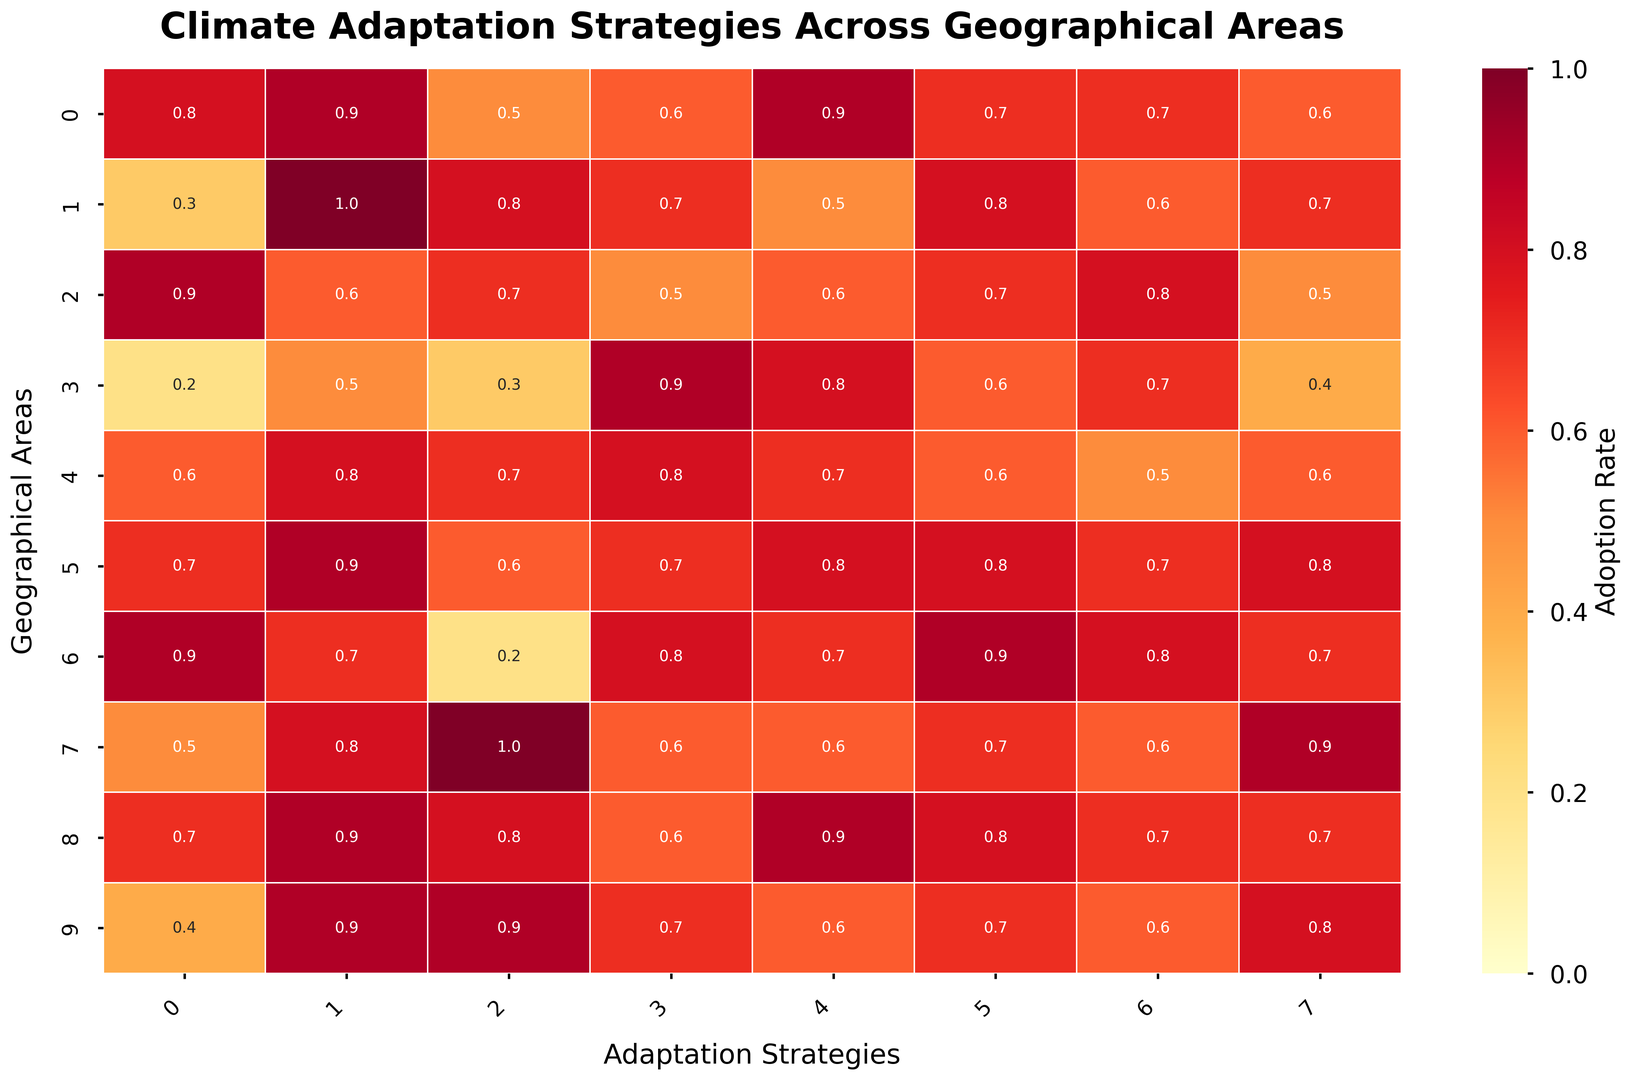What's the most adopted climate adaptation strategy in Coastal Regions? First, identify the row corresponding to Coastal Regions. Then, look across the row to find the highest value. The column with the highest value represents the most adopted strategy.
Answer: Water Conservation Which geographical area has the lowest adoption rate for Urban Greening? Look down the Urban Greening column to find the smallest value and identify which row it corresponds to.
Answer: Arctic Areas Which two geographical areas have the same adoption rate for Health Adaptation Measures? Identify and compare the values in the Health Adaptation Measures column. Locate the rows where the values are the same.
Answer: Coastal Regions and River Deltas What is the difference in the adoption rate of Energy Efficient Housing between Arctic Areas and Tropical Rainforests? Identify the values for Energy Efficient Housing in Arctic Areas (0.9) and Tropical Rainforests (0.5). Subtract the lower value from the higher value: 0.9 - 0.5.
Answer: 0.4 Which geographical area has the highest overall adoption across all strategies? For this, calculate the average adoption rate for each row and identify the row with the highest average. Coastal Regions: Average of (0.8+0.9+0.5+0.6+0.9+0.7+0.7+0.6) = 5.7/8 = 0.7125 Arid Zones: Average of (0.3+1.0+0.8+0.7+0.5+0.8+0.6+0.7)= 5.4/8 = 0.675 Tropical Rainforests: Average of (0.9+0.6+0.7+0.5+0.6+0.7+0.8+0.5)= 5.3/8= 0.6625 Arctic Areas: Average of (0.2+0.5+0.3+0.9+0.8+0.6+0.7+0.4)= 4.4/8= 0.55 Mountain Regions: Average of (0.6+0.8+0.7+0.8+0.7+0.6+0.5+0.6)= 5.3/8= 0.6625 Islands: Average of (0.7+0.9+0.6+0.7+0.8+0.8+0.7+0.8)= 6.0/8= 0.75 Urban Centers: Average of (0.9+0.7+0.2+0.8+0.7+0.9+0.8+0.7)= 5.7/8= 0.7125 Agricultural Plains: Average of (0.5+0.8+1.0+0.6+0.6+0.7+0.6+0.9)= 5.7/8= 0.7125 River Deltas: Average of (0.7+0.9+0.8+0.6+0.9+0.8+0.7+0.7)= 6.1/8= 0.7625 Semi-Arid Grasslands: Average of (0.4+0.9+0.9+0.7+0.6+0.7+0.6+0.8)= 5.6/8=0.7 Hence River Deltas have the highest overall adoption
Answer: River Deltas Which adaptation strategy shows the least variation in adoption rates across all geographical areas? Calculate the variance for each column (adaptation strategy) and compare. Water Conservation column: sum=8.2 mean=0.82 sum of squares:0.64,0.0361,0.64,0.0961,0.0361,0.0361,0.0144,0.0144,0.0144,0.0144=0.7363 Sustainable Agriculture column: sum=6.30 mean 0.63 sum of squares:0.0009,0.2896,0.0009,0.1089,0.0041,0.0036,0.1849,0.0036,0.1849,0.0009=0.7783 per this Water conservation has the least variance
Answer: Water Conservation Which three geographical areas have the most similar adoption rates for Community Education Programs? Calculate and compare the pairwise differences in the values for Community Education Programs for each geographical area. Find the three areas with the smallest total differences. Coastal: 0.7, Arid: 0.8, Tropical: 0.7 Arctic: 0.6 Mountain: 0.6 Islands: 0.8 Urban: 0.9 agri: 0.7 Delta: 0.8 Semi arid:0.7 hence coastal,tropical,agri
Answer: Coastal Regions, Tropical Rainforests, and Agricultural Plains Is there any geographical area where Sustainable Agriculture is practiced more than Urban Centers? Compare the values for Sustainable Agriculture in each row with the value in the row corresponding to Urban Centers, which is 0.2.
Answer: Yes, all except Urban Centers How many geographical areas have an adoption rate of 0.8 or higher for Disaster-Resistant Infrastructure? Look through the Disaster-Resistant Infrastructure column for values that are 0.8 or higher and count how many rows meet this criterion.
Answer: 5 